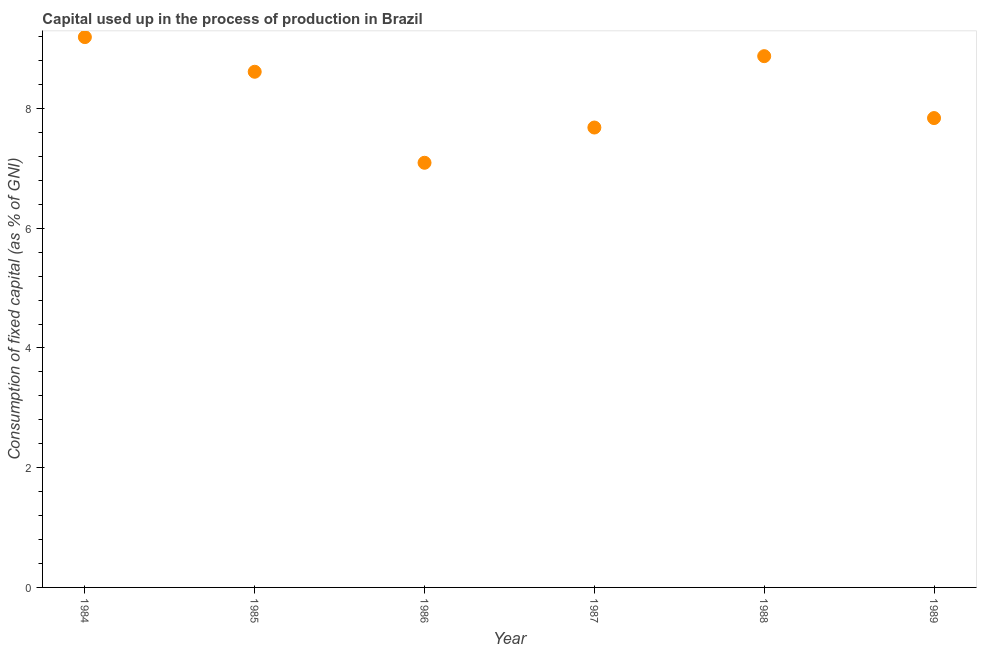What is the consumption of fixed capital in 1986?
Offer a terse response. 7.09. Across all years, what is the maximum consumption of fixed capital?
Give a very brief answer. 9.19. Across all years, what is the minimum consumption of fixed capital?
Your response must be concise. 7.09. In which year was the consumption of fixed capital maximum?
Give a very brief answer. 1984. What is the sum of the consumption of fixed capital?
Keep it short and to the point. 49.3. What is the difference between the consumption of fixed capital in 1985 and 1986?
Your response must be concise. 1.52. What is the average consumption of fixed capital per year?
Keep it short and to the point. 8.22. What is the median consumption of fixed capital?
Provide a short and direct response. 8.23. In how many years, is the consumption of fixed capital greater than 6.8 %?
Keep it short and to the point. 6. Do a majority of the years between 1987 and 1984 (inclusive) have consumption of fixed capital greater than 7.2 %?
Offer a terse response. Yes. What is the ratio of the consumption of fixed capital in 1984 to that in 1985?
Make the answer very short. 1.07. Is the consumption of fixed capital in 1986 less than that in 1989?
Your answer should be compact. Yes. Is the difference between the consumption of fixed capital in 1984 and 1988 greater than the difference between any two years?
Provide a succinct answer. No. What is the difference between the highest and the second highest consumption of fixed capital?
Keep it short and to the point. 0.32. What is the difference between the highest and the lowest consumption of fixed capital?
Your answer should be very brief. 2.1. In how many years, is the consumption of fixed capital greater than the average consumption of fixed capital taken over all years?
Offer a terse response. 3. How many years are there in the graph?
Give a very brief answer. 6. What is the title of the graph?
Your answer should be compact. Capital used up in the process of production in Brazil. What is the label or title of the X-axis?
Keep it short and to the point. Year. What is the label or title of the Y-axis?
Your response must be concise. Consumption of fixed capital (as % of GNI). What is the Consumption of fixed capital (as % of GNI) in 1984?
Your answer should be compact. 9.19. What is the Consumption of fixed capital (as % of GNI) in 1985?
Make the answer very short. 8.61. What is the Consumption of fixed capital (as % of GNI) in 1986?
Give a very brief answer. 7.09. What is the Consumption of fixed capital (as % of GNI) in 1987?
Your answer should be compact. 7.68. What is the Consumption of fixed capital (as % of GNI) in 1988?
Your response must be concise. 8.87. What is the Consumption of fixed capital (as % of GNI) in 1989?
Ensure brevity in your answer.  7.84. What is the difference between the Consumption of fixed capital (as % of GNI) in 1984 and 1985?
Your response must be concise. 0.58. What is the difference between the Consumption of fixed capital (as % of GNI) in 1984 and 1986?
Your answer should be very brief. 2.1. What is the difference between the Consumption of fixed capital (as % of GNI) in 1984 and 1987?
Provide a succinct answer. 1.51. What is the difference between the Consumption of fixed capital (as % of GNI) in 1984 and 1988?
Your answer should be very brief. 0.32. What is the difference between the Consumption of fixed capital (as % of GNI) in 1984 and 1989?
Give a very brief answer. 1.35. What is the difference between the Consumption of fixed capital (as % of GNI) in 1985 and 1986?
Offer a very short reply. 1.52. What is the difference between the Consumption of fixed capital (as % of GNI) in 1985 and 1987?
Offer a very short reply. 0.93. What is the difference between the Consumption of fixed capital (as % of GNI) in 1985 and 1988?
Ensure brevity in your answer.  -0.26. What is the difference between the Consumption of fixed capital (as % of GNI) in 1985 and 1989?
Your answer should be compact. 0.77. What is the difference between the Consumption of fixed capital (as % of GNI) in 1986 and 1987?
Your response must be concise. -0.59. What is the difference between the Consumption of fixed capital (as % of GNI) in 1986 and 1988?
Give a very brief answer. -1.78. What is the difference between the Consumption of fixed capital (as % of GNI) in 1986 and 1989?
Give a very brief answer. -0.75. What is the difference between the Consumption of fixed capital (as % of GNI) in 1987 and 1988?
Give a very brief answer. -1.19. What is the difference between the Consumption of fixed capital (as % of GNI) in 1987 and 1989?
Ensure brevity in your answer.  -0.16. What is the difference between the Consumption of fixed capital (as % of GNI) in 1988 and 1989?
Keep it short and to the point. 1.03. What is the ratio of the Consumption of fixed capital (as % of GNI) in 1984 to that in 1985?
Your response must be concise. 1.07. What is the ratio of the Consumption of fixed capital (as % of GNI) in 1984 to that in 1986?
Provide a succinct answer. 1.3. What is the ratio of the Consumption of fixed capital (as % of GNI) in 1984 to that in 1987?
Offer a terse response. 1.2. What is the ratio of the Consumption of fixed capital (as % of GNI) in 1984 to that in 1988?
Give a very brief answer. 1.04. What is the ratio of the Consumption of fixed capital (as % of GNI) in 1984 to that in 1989?
Provide a short and direct response. 1.17. What is the ratio of the Consumption of fixed capital (as % of GNI) in 1985 to that in 1986?
Your response must be concise. 1.21. What is the ratio of the Consumption of fixed capital (as % of GNI) in 1985 to that in 1987?
Ensure brevity in your answer.  1.12. What is the ratio of the Consumption of fixed capital (as % of GNI) in 1985 to that in 1989?
Keep it short and to the point. 1.1. What is the ratio of the Consumption of fixed capital (as % of GNI) in 1986 to that in 1987?
Offer a terse response. 0.92. What is the ratio of the Consumption of fixed capital (as % of GNI) in 1986 to that in 1988?
Keep it short and to the point. 0.8. What is the ratio of the Consumption of fixed capital (as % of GNI) in 1986 to that in 1989?
Give a very brief answer. 0.91. What is the ratio of the Consumption of fixed capital (as % of GNI) in 1987 to that in 1988?
Keep it short and to the point. 0.87. What is the ratio of the Consumption of fixed capital (as % of GNI) in 1987 to that in 1989?
Give a very brief answer. 0.98. What is the ratio of the Consumption of fixed capital (as % of GNI) in 1988 to that in 1989?
Your answer should be very brief. 1.13. 